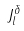Convert formula to latex. <formula><loc_0><loc_0><loc_500><loc_500>J _ { l } ^ { \delta }</formula> 